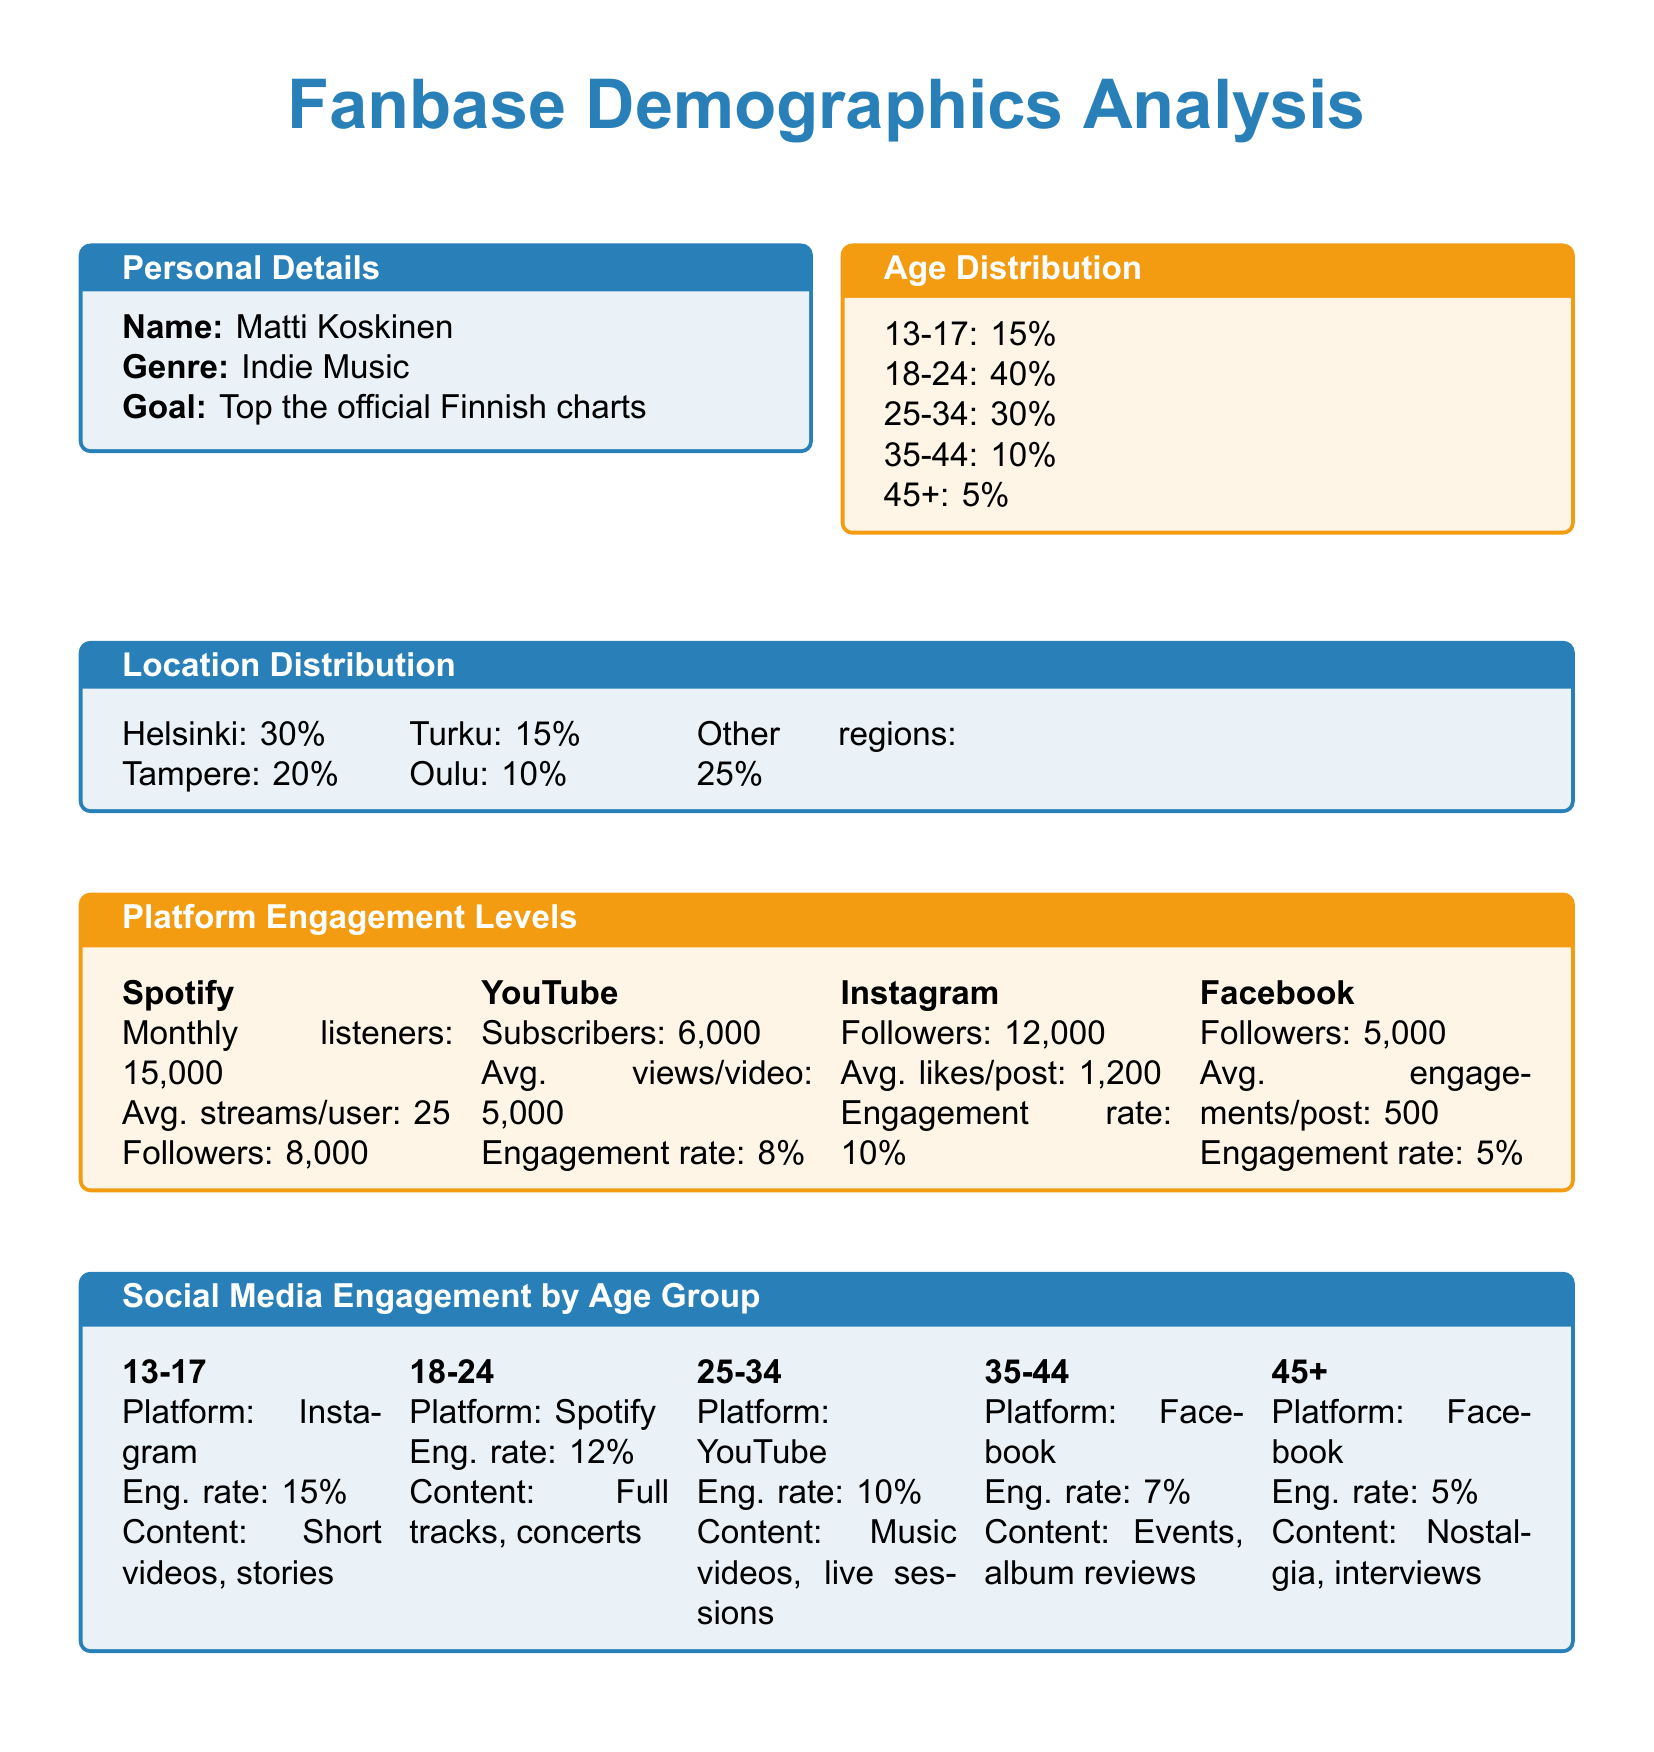What is the age group with the highest percentage? The age group 18-24 has the highest percentage at 40%.
Answer: 18-24 What percentage of listeners are from Helsinki? The document states that 30% of listeners are from Helsinki.
Answer: 30% How many monthly listeners does Matti Koskinen have on Spotify? The monthly listeners on Spotify are reported as 15,000.
Answer: 15,000 Which social media platform has the highest engagement rate for the 13-17 age group? The engagement rate for this age group is highest on Instagram at 15%.
Answer: Instagram What is the average likes per post on Instagram? The average likes per post on Instagram is reported as 1,200.
Answer: 1,200 What is the engagement rate on Facebook for the 35-44 age group? The engagement rate for this age group on Facebook is 7%.
Answer: 7% What is the total percentage of listeners from Oulu and Turku combined? The combined percentage of listeners from Oulu (10%) and Turku (15%) is 25%.
Answer: 25% Which platform has the lowest engagement rate? Facebook has the lowest engagement rate at 5%.
Answer: 5% How many followers does Matti Koskinen have on Facebook? The total number of followers on Facebook is given as 5,000.
Answer: 5,000 